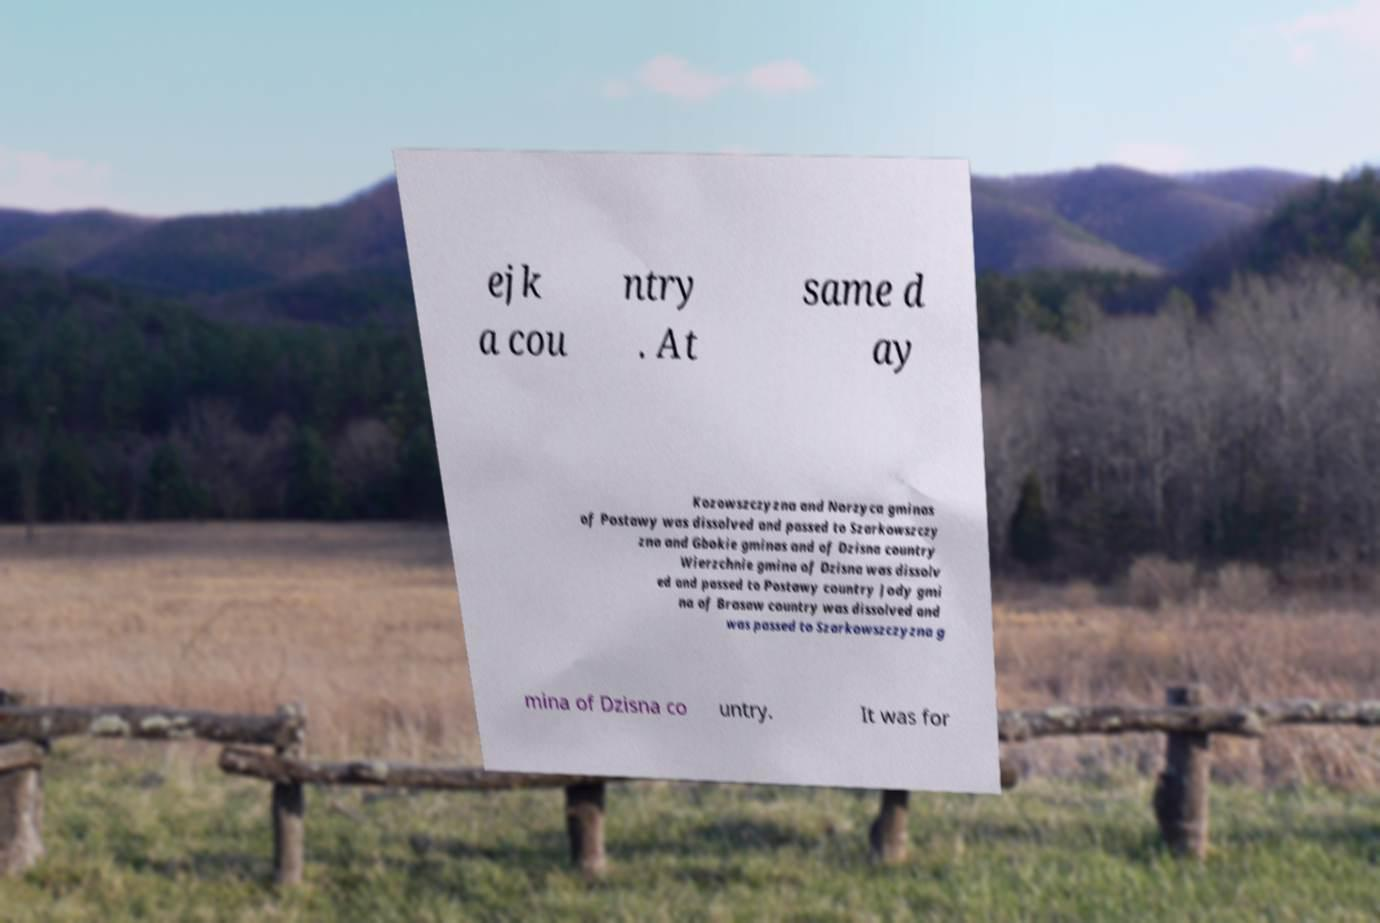Can you read and provide the text displayed in the image?This photo seems to have some interesting text. Can you extract and type it out for me? ejk a cou ntry . At same d ay Kozowszczyzna and Norzyca gminas of Postawy was dissolved and passed to Szarkowszczy zna and Gbokie gminas and of Dzisna country Wierzchnie gmina of Dzisna was dissolv ed and passed to Postawy country Jody gmi na of Brasaw country was dissolved and was passed to Szarkowszczyzna g mina of Dzisna co untry. It was for 